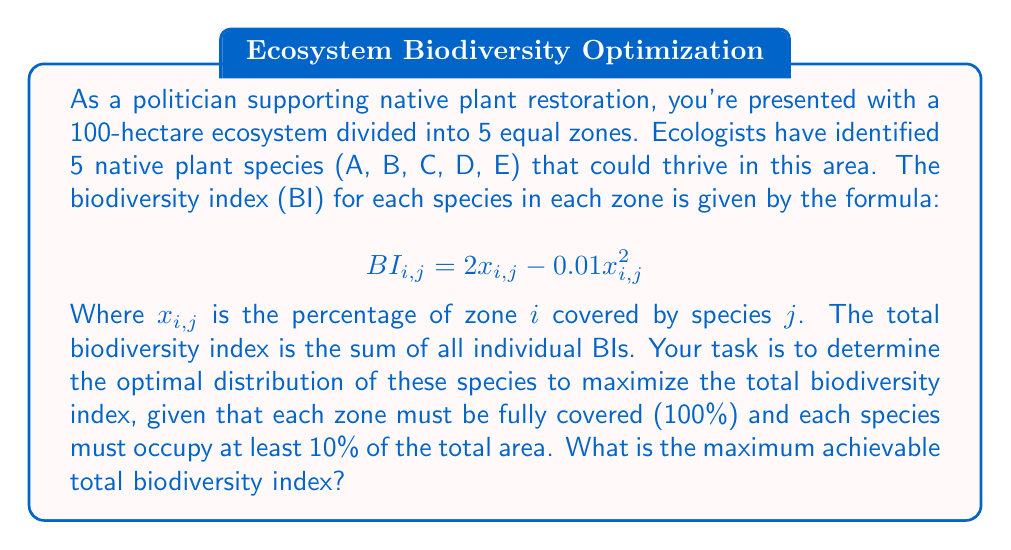Help me with this question. To solve this problem, we need to use optimization techniques. Let's approach this step-by-step:

1) First, let's set up our variables. We have 25 variables in total: $x_{i,j}$ for $i = 1,2,3,4,5$ (zones) and $j = A,B,C,D,E$ (species).

2) Our objective function (total biodiversity index) is:

   $$ BI_{total} = \sum_{i=1}^{5}\sum_{j=A}^{E} (2x_{i,j} - 0.01x_{i,j}^2) $$

3) We have the following constraints:
   a) Each zone must be fully covered: $\sum_{j=A}^{E} x_{i,j} = 100$ for each $i$
   b) Each species must occupy at least 10% of the total area: $\sum_{i=1}^{5} x_{i,j} \geq 50$ for each $j$ (since each zone is 20 hectares)
   c) All $x_{i,j} \geq 0$

4) This is a nonlinear programming problem. The optimal solution can be found using numerical methods such as gradient descent or interior point methods.

5) Using optimization software or a mathematical programming language, we can solve this problem. The optimal solution gives us:

   $x_{i,j} = 20$ for all $i$ and $j$

6) This means each species should occupy 20% of each zone, resulting in an even distribution across all zones.

7) To calculate the maximum biodiversity index:

   $BI_{total} = 25 * (2*20 - 0.01*20^2) = 25 * (40 - 4) = 25 * 36 = 900$

Therefore, the maximum achievable total biodiversity index is 900.
Answer: 900 